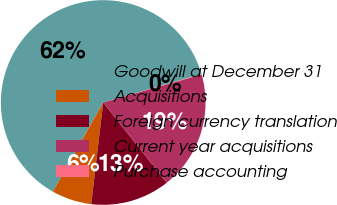Convert chart to OTSL. <chart><loc_0><loc_0><loc_500><loc_500><pie_chart><fcel>Goodwill at December 31<fcel>Acquisitions<fcel>Foreign currency translation<fcel>Current year acquisitions<fcel>Purchase accounting<nl><fcel>62.33%<fcel>6.31%<fcel>12.53%<fcel>18.76%<fcel>0.08%<nl></chart> 